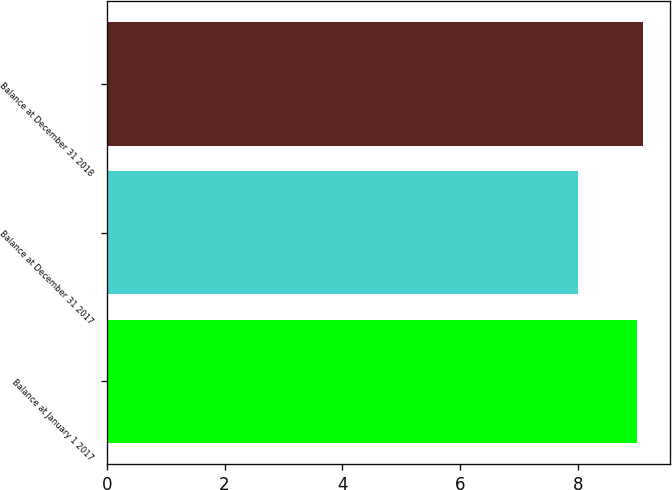Convert chart. <chart><loc_0><loc_0><loc_500><loc_500><bar_chart><fcel>Balance at January 1 2017<fcel>Balance at December 31 2017<fcel>Balance at December 31 2018<nl><fcel>9<fcel>8<fcel>9.1<nl></chart> 